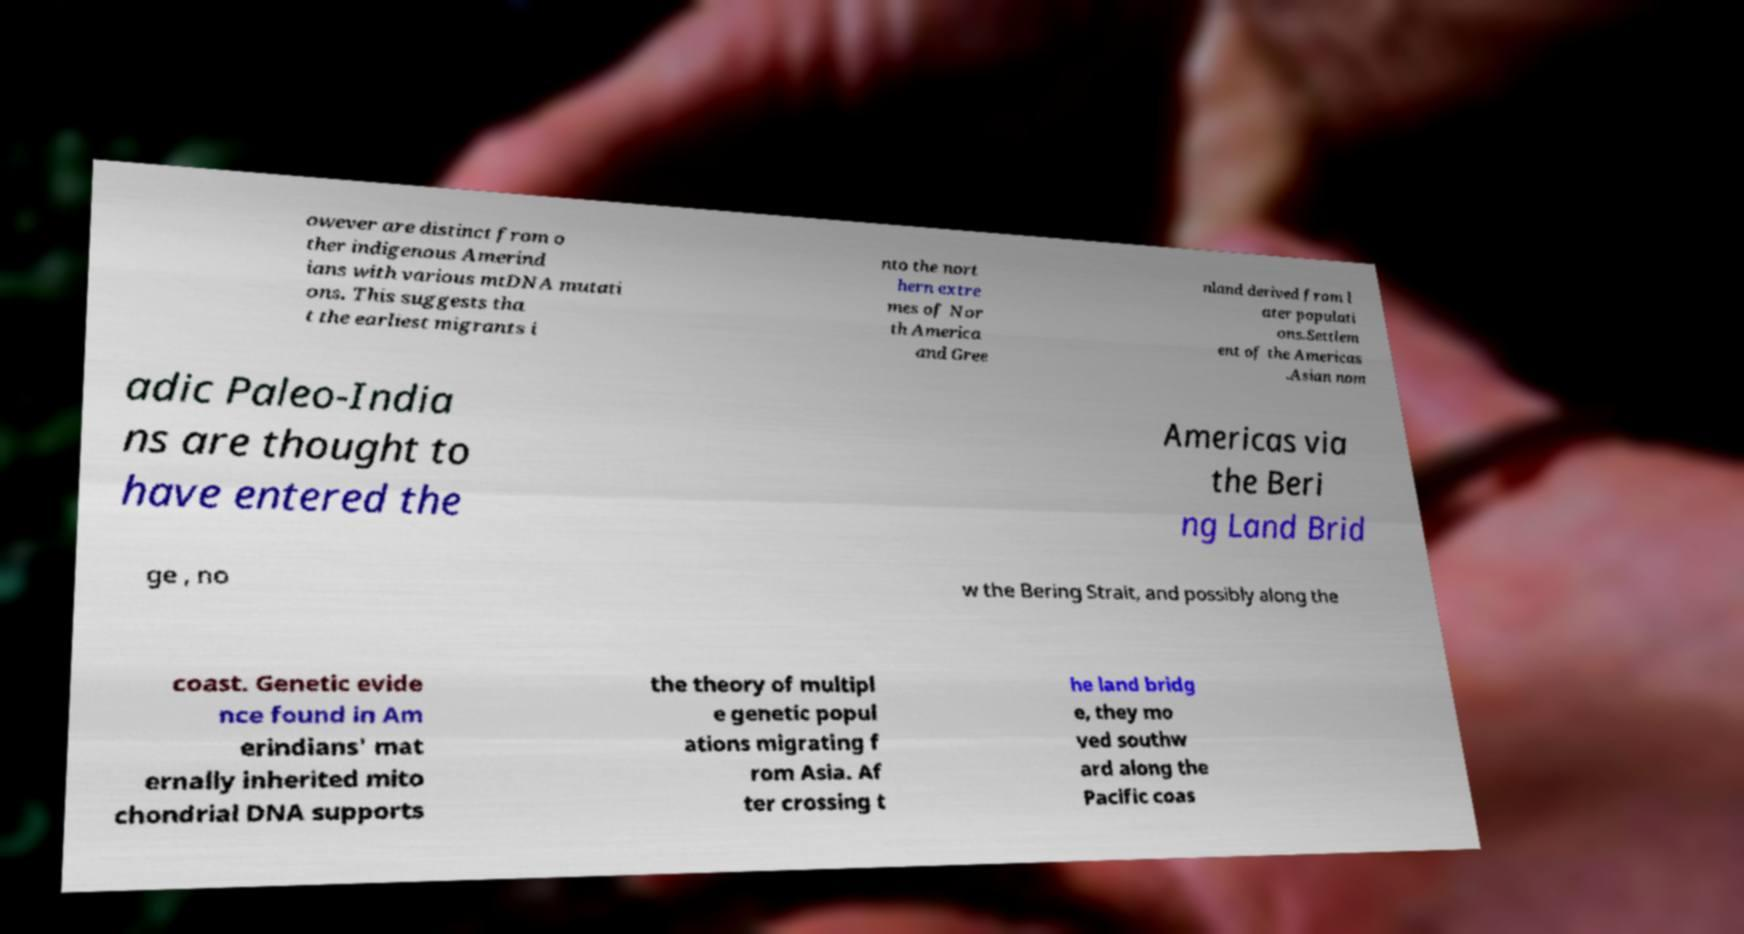What messages or text are displayed in this image? I need them in a readable, typed format. owever are distinct from o ther indigenous Amerind ians with various mtDNA mutati ons. This suggests tha t the earliest migrants i nto the nort hern extre mes of Nor th America and Gree nland derived from l ater populati ons.Settlem ent of the Americas .Asian nom adic Paleo-India ns are thought to have entered the Americas via the Beri ng Land Brid ge , no w the Bering Strait, and possibly along the coast. Genetic evide nce found in Am erindians' mat ernally inherited mito chondrial DNA supports the theory of multipl e genetic popul ations migrating f rom Asia. Af ter crossing t he land bridg e, they mo ved southw ard along the Pacific coas 